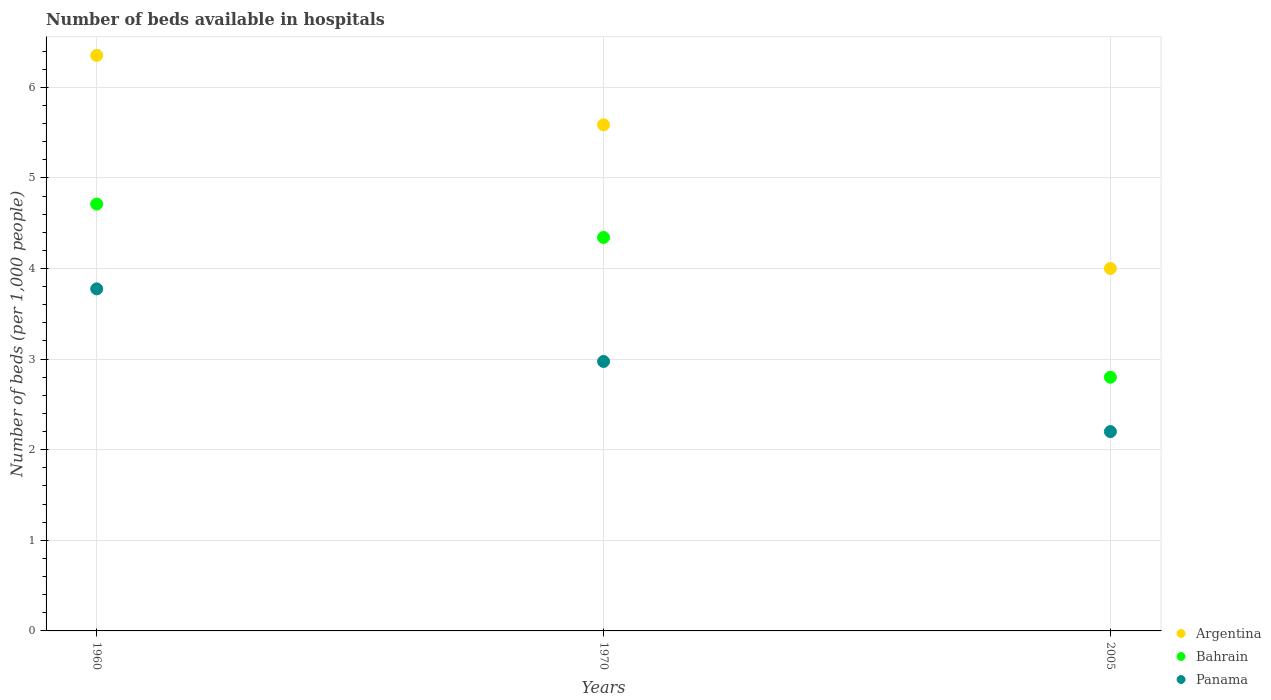How many different coloured dotlines are there?
Your answer should be very brief. 3. Is the number of dotlines equal to the number of legend labels?
Provide a succinct answer. Yes. What is the number of beds in the hospiatls of in Panama in 1970?
Provide a succinct answer. 2.97. Across all years, what is the maximum number of beds in the hospiatls of in Argentina?
Provide a succinct answer. 6.35. In which year was the number of beds in the hospiatls of in Bahrain maximum?
Offer a very short reply. 1960. In which year was the number of beds in the hospiatls of in Argentina minimum?
Provide a short and direct response. 2005. What is the total number of beds in the hospiatls of in Panama in the graph?
Make the answer very short. 8.95. What is the difference between the number of beds in the hospiatls of in Bahrain in 1960 and that in 1970?
Your answer should be compact. 0.37. What is the difference between the number of beds in the hospiatls of in Argentina in 1960 and the number of beds in the hospiatls of in Panama in 1970?
Keep it short and to the point. 3.38. What is the average number of beds in the hospiatls of in Panama per year?
Your answer should be very brief. 2.98. In the year 1970, what is the difference between the number of beds in the hospiatls of in Panama and number of beds in the hospiatls of in Argentina?
Give a very brief answer. -2.61. What is the ratio of the number of beds in the hospiatls of in Bahrain in 1970 to that in 2005?
Your answer should be very brief. 1.55. Is the difference between the number of beds in the hospiatls of in Panama in 1960 and 1970 greater than the difference between the number of beds in the hospiatls of in Argentina in 1960 and 1970?
Your response must be concise. Yes. What is the difference between the highest and the second highest number of beds in the hospiatls of in Argentina?
Offer a terse response. 0.77. What is the difference between the highest and the lowest number of beds in the hospiatls of in Panama?
Provide a short and direct response. 1.58. In how many years, is the number of beds in the hospiatls of in Argentina greater than the average number of beds in the hospiatls of in Argentina taken over all years?
Your response must be concise. 2. Is the number of beds in the hospiatls of in Argentina strictly greater than the number of beds in the hospiatls of in Panama over the years?
Give a very brief answer. Yes. Is the number of beds in the hospiatls of in Bahrain strictly less than the number of beds in the hospiatls of in Panama over the years?
Give a very brief answer. No. How many dotlines are there?
Offer a very short reply. 3. How many years are there in the graph?
Your response must be concise. 3. Are the values on the major ticks of Y-axis written in scientific E-notation?
Your answer should be very brief. No. Where does the legend appear in the graph?
Make the answer very short. Bottom right. How many legend labels are there?
Your answer should be very brief. 3. How are the legend labels stacked?
Give a very brief answer. Vertical. What is the title of the graph?
Offer a very short reply. Number of beds available in hospitals. What is the label or title of the X-axis?
Offer a terse response. Years. What is the label or title of the Y-axis?
Keep it short and to the point. Number of beds (per 1,0 people). What is the Number of beds (per 1,000 people) of Argentina in 1960?
Offer a terse response. 6.35. What is the Number of beds (per 1,000 people) in Bahrain in 1960?
Keep it short and to the point. 4.71. What is the Number of beds (per 1,000 people) in Panama in 1960?
Your response must be concise. 3.78. What is the Number of beds (per 1,000 people) of Argentina in 1970?
Your answer should be compact. 5.59. What is the Number of beds (per 1,000 people) of Bahrain in 1970?
Offer a very short reply. 4.34. What is the Number of beds (per 1,000 people) in Panama in 1970?
Offer a terse response. 2.97. Across all years, what is the maximum Number of beds (per 1,000 people) in Argentina?
Give a very brief answer. 6.35. Across all years, what is the maximum Number of beds (per 1,000 people) in Bahrain?
Make the answer very short. 4.71. Across all years, what is the maximum Number of beds (per 1,000 people) of Panama?
Provide a succinct answer. 3.78. Across all years, what is the minimum Number of beds (per 1,000 people) in Argentina?
Offer a very short reply. 4. Across all years, what is the minimum Number of beds (per 1,000 people) of Panama?
Keep it short and to the point. 2.2. What is the total Number of beds (per 1,000 people) in Argentina in the graph?
Offer a terse response. 15.94. What is the total Number of beds (per 1,000 people) of Bahrain in the graph?
Your answer should be compact. 11.85. What is the total Number of beds (per 1,000 people) in Panama in the graph?
Your response must be concise. 8.95. What is the difference between the Number of beds (per 1,000 people) in Argentina in 1960 and that in 1970?
Offer a very short reply. 0.77. What is the difference between the Number of beds (per 1,000 people) in Bahrain in 1960 and that in 1970?
Provide a succinct answer. 0.37. What is the difference between the Number of beds (per 1,000 people) of Panama in 1960 and that in 1970?
Give a very brief answer. 0.8. What is the difference between the Number of beds (per 1,000 people) of Argentina in 1960 and that in 2005?
Your answer should be very brief. 2.35. What is the difference between the Number of beds (per 1,000 people) in Bahrain in 1960 and that in 2005?
Keep it short and to the point. 1.91. What is the difference between the Number of beds (per 1,000 people) in Panama in 1960 and that in 2005?
Your response must be concise. 1.58. What is the difference between the Number of beds (per 1,000 people) of Argentina in 1970 and that in 2005?
Your response must be concise. 1.59. What is the difference between the Number of beds (per 1,000 people) of Bahrain in 1970 and that in 2005?
Your answer should be compact. 1.54. What is the difference between the Number of beds (per 1,000 people) of Panama in 1970 and that in 2005?
Ensure brevity in your answer.  0.77. What is the difference between the Number of beds (per 1,000 people) in Argentina in 1960 and the Number of beds (per 1,000 people) in Bahrain in 1970?
Offer a very short reply. 2.01. What is the difference between the Number of beds (per 1,000 people) of Argentina in 1960 and the Number of beds (per 1,000 people) of Panama in 1970?
Your response must be concise. 3.38. What is the difference between the Number of beds (per 1,000 people) in Bahrain in 1960 and the Number of beds (per 1,000 people) in Panama in 1970?
Ensure brevity in your answer.  1.74. What is the difference between the Number of beds (per 1,000 people) in Argentina in 1960 and the Number of beds (per 1,000 people) in Bahrain in 2005?
Provide a succinct answer. 3.55. What is the difference between the Number of beds (per 1,000 people) of Argentina in 1960 and the Number of beds (per 1,000 people) of Panama in 2005?
Keep it short and to the point. 4.15. What is the difference between the Number of beds (per 1,000 people) of Bahrain in 1960 and the Number of beds (per 1,000 people) of Panama in 2005?
Give a very brief answer. 2.51. What is the difference between the Number of beds (per 1,000 people) of Argentina in 1970 and the Number of beds (per 1,000 people) of Bahrain in 2005?
Offer a terse response. 2.79. What is the difference between the Number of beds (per 1,000 people) of Argentina in 1970 and the Number of beds (per 1,000 people) of Panama in 2005?
Make the answer very short. 3.39. What is the difference between the Number of beds (per 1,000 people) in Bahrain in 1970 and the Number of beds (per 1,000 people) in Panama in 2005?
Your answer should be very brief. 2.14. What is the average Number of beds (per 1,000 people) of Argentina per year?
Offer a terse response. 5.31. What is the average Number of beds (per 1,000 people) in Bahrain per year?
Provide a short and direct response. 3.95. What is the average Number of beds (per 1,000 people) in Panama per year?
Your answer should be very brief. 2.98. In the year 1960, what is the difference between the Number of beds (per 1,000 people) in Argentina and Number of beds (per 1,000 people) in Bahrain?
Your answer should be compact. 1.64. In the year 1960, what is the difference between the Number of beds (per 1,000 people) in Argentina and Number of beds (per 1,000 people) in Panama?
Your answer should be very brief. 2.58. In the year 1960, what is the difference between the Number of beds (per 1,000 people) of Bahrain and Number of beds (per 1,000 people) of Panama?
Give a very brief answer. 0.94. In the year 1970, what is the difference between the Number of beds (per 1,000 people) of Argentina and Number of beds (per 1,000 people) of Bahrain?
Make the answer very short. 1.24. In the year 1970, what is the difference between the Number of beds (per 1,000 people) of Argentina and Number of beds (per 1,000 people) of Panama?
Keep it short and to the point. 2.61. In the year 1970, what is the difference between the Number of beds (per 1,000 people) in Bahrain and Number of beds (per 1,000 people) in Panama?
Your answer should be very brief. 1.37. In the year 2005, what is the difference between the Number of beds (per 1,000 people) in Argentina and Number of beds (per 1,000 people) in Bahrain?
Offer a terse response. 1.2. In the year 2005, what is the difference between the Number of beds (per 1,000 people) of Argentina and Number of beds (per 1,000 people) of Panama?
Your answer should be compact. 1.8. In the year 2005, what is the difference between the Number of beds (per 1,000 people) in Bahrain and Number of beds (per 1,000 people) in Panama?
Offer a terse response. 0.6. What is the ratio of the Number of beds (per 1,000 people) of Argentina in 1960 to that in 1970?
Offer a very short reply. 1.14. What is the ratio of the Number of beds (per 1,000 people) in Bahrain in 1960 to that in 1970?
Your answer should be very brief. 1.08. What is the ratio of the Number of beds (per 1,000 people) in Panama in 1960 to that in 1970?
Your answer should be compact. 1.27. What is the ratio of the Number of beds (per 1,000 people) of Argentina in 1960 to that in 2005?
Your answer should be compact. 1.59. What is the ratio of the Number of beds (per 1,000 people) of Bahrain in 1960 to that in 2005?
Provide a succinct answer. 1.68. What is the ratio of the Number of beds (per 1,000 people) of Panama in 1960 to that in 2005?
Your answer should be compact. 1.72. What is the ratio of the Number of beds (per 1,000 people) of Argentina in 1970 to that in 2005?
Your answer should be very brief. 1.4. What is the ratio of the Number of beds (per 1,000 people) in Bahrain in 1970 to that in 2005?
Your answer should be compact. 1.55. What is the ratio of the Number of beds (per 1,000 people) in Panama in 1970 to that in 2005?
Ensure brevity in your answer.  1.35. What is the difference between the highest and the second highest Number of beds (per 1,000 people) of Argentina?
Make the answer very short. 0.77. What is the difference between the highest and the second highest Number of beds (per 1,000 people) in Bahrain?
Ensure brevity in your answer.  0.37. What is the difference between the highest and the second highest Number of beds (per 1,000 people) in Panama?
Provide a succinct answer. 0.8. What is the difference between the highest and the lowest Number of beds (per 1,000 people) in Argentina?
Provide a succinct answer. 2.35. What is the difference between the highest and the lowest Number of beds (per 1,000 people) of Bahrain?
Ensure brevity in your answer.  1.91. What is the difference between the highest and the lowest Number of beds (per 1,000 people) in Panama?
Offer a terse response. 1.58. 